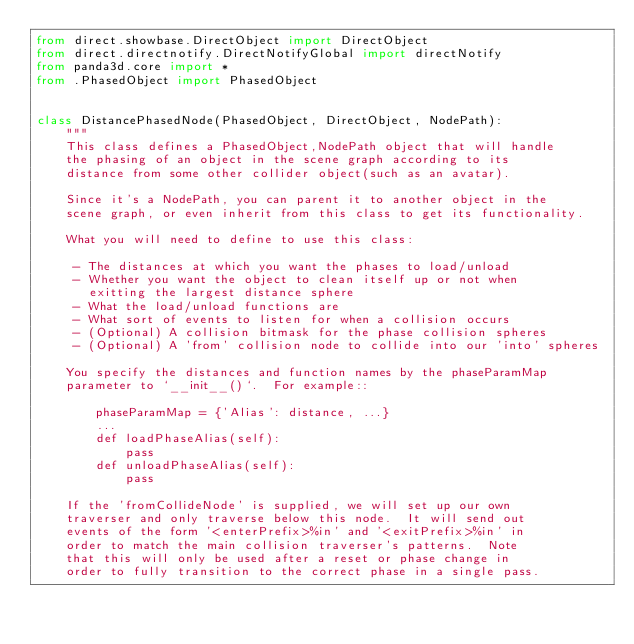<code> <loc_0><loc_0><loc_500><loc_500><_Python_>from direct.showbase.DirectObject import DirectObject
from direct.directnotify.DirectNotifyGlobal import directNotify
from panda3d.core import *
from .PhasedObject import PhasedObject


class DistancePhasedNode(PhasedObject, DirectObject, NodePath):
    """
    This class defines a PhasedObject,NodePath object that will handle
    the phasing of an object in the scene graph according to its
    distance from some other collider object(such as an avatar).

    Since it's a NodePath, you can parent it to another object in the
    scene graph, or even inherit from this class to get its functionality.

    What you will need to define to use this class:

     - The distances at which you want the phases to load/unload
     - Whether you want the object to clean itself up or not when
       exitting the largest distance sphere
     - What the load/unload functions are
     - What sort of events to listen for when a collision occurs
     - (Optional) A collision bitmask for the phase collision spheres
     - (Optional) A 'from' collision node to collide into our 'into' spheres

    You specify the distances and function names by the phaseParamMap
    parameter to `__init__()`.  For example::

        phaseParamMap = {'Alias': distance, ...}
        ...
        def loadPhaseAlias(self):
            pass
        def unloadPhaseAlias(self):
            pass

    If the 'fromCollideNode' is supplied, we will set up our own
    traverser and only traverse below this node.  It will send out
    events of the form '<enterPrefix>%in' and '<exitPrefix>%in' in
    order to match the main collision traverser's patterns.  Note
    that this will only be used after a reset or phase change in
    order to fully transition to the correct phase in a single pass.</code> 